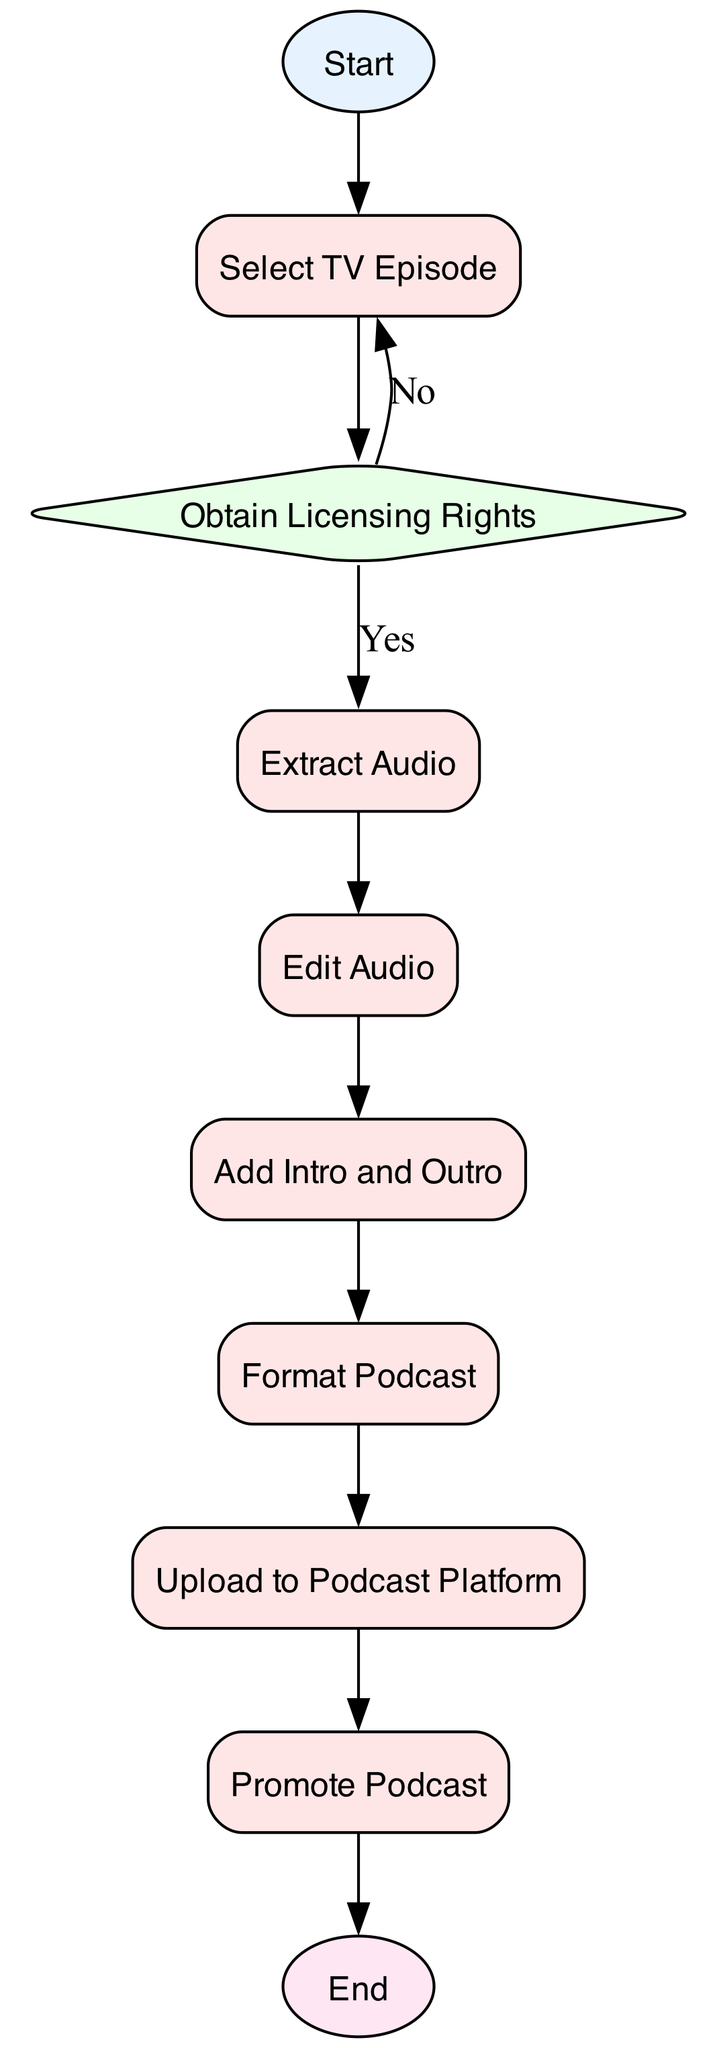What is the first step in the workflow? The first step is indicated as "Start" in the diagram, which marks the beginning of the workflow process.
Answer: Start How many processes are in the workflow? By reviewing the diagram, I can identify five process nodes: "Select TV Episode," "Extract Audio," "Edit Audio," "Add Intro and Outro," and "Format Podcast."
Answer: Five What happens if licensing rights are not obtained? If the licensing rights are not obtained, the workflow indicates to go back to the "Select TV Episode" node, implying that another episode must be chosen for conversion.
Answer: Select TV Episode What is the final step in the workflow? The final step is indicated as "End," which signifies the completion of the workflow after all preceding actions have taken place.
Answer: End Which node comes immediately after "Edit Audio"? The node that follows "Edit Audio" in the sequence is "Add Intro and Outro," indicating the next step in the process.
Answer: Add Intro and Outro What must be done before uploading the podcast? Before uploading the podcast, the audio file must be formatted correctly, which is represented by the "Format Podcast" process in the workflow.
Answer: Format Podcast How many decision points are in the workflow? There is one decision point in the workflow, labeled "Obtain Licensing Rights," which checks for the required rights before proceeding.
Answer: One What is required to be added at the "Add Intro and Outro" step? At the "Add Intro and Outro" step, the workflow specifies that an introductory and closing segment should be added, possibly along with a voiceover.
Answer: Introductory and closing segment What is the process that directly follows "Upload to Podcast Platform"? The process that comes right after "Upload to Podcast Platform" is "Promote Podcast," as shown by the connecting edge in the workflow diagram.
Answer: Promote Podcast 